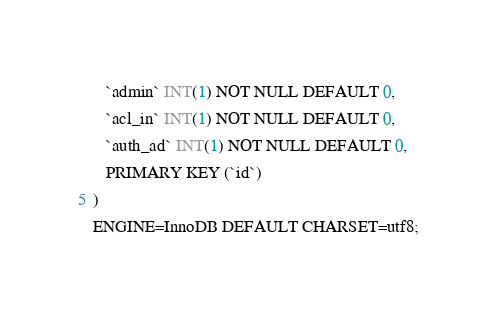Convert code to text. <code><loc_0><loc_0><loc_500><loc_500><_SQL_>   `admin` INT(1) NOT NULL DEFAULT 0,
   `acl_in` INT(1) NOT NULL DEFAULT 0,
   `auth_ad` INT(1) NOT NULL DEFAULT 0,
   PRIMARY KEY (`id`)
)
ENGINE=InnoDB DEFAULT CHARSET=utf8;
</code> 